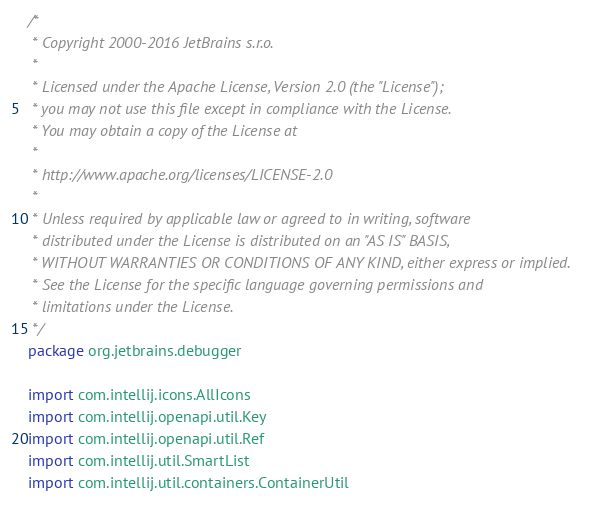Convert code to text. <code><loc_0><loc_0><loc_500><loc_500><_Kotlin_>/*
 * Copyright 2000-2016 JetBrains s.r.o.
 *
 * Licensed under the Apache License, Version 2.0 (the "License");
 * you may not use this file except in compliance with the License.
 * You may obtain a copy of the License at
 *
 * http://www.apache.org/licenses/LICENSE-2.0
 *
 * Unless required by applicable law or agreed to in writing, software
 * distributed under the License is distributed on an "AS IS" BASIS,
 * WITHOUT WARRANTIES OR CONDITIONS OF ANY KIND, either express or implied.
 * See the License for the specific language governing permissions and
 * limitations under the License.
 */
package org.jetbrains.debugger

import com.intellij.icons.AllIcons
import com.intellij.openapi.util.Key
import com.intellij.openapi.util.Ref
import com.intellij.util.SmartList
import com.intellij.util.containers.ContainerUtil</code> 